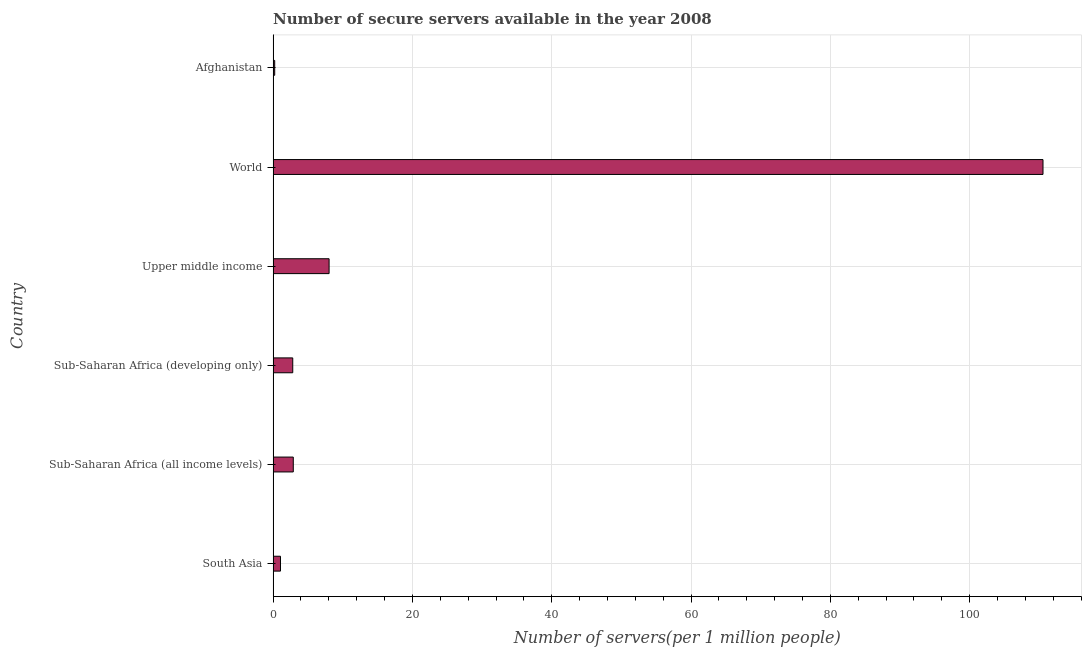Does the graph contain any zero values?
Your answer should be very brief. No. What is the title of the graph?
Offer a very short reply. Number of secure servers available in the year 2008. What is the label or title of the X-axis?
Your answer should be very brief. Number of servers(per 1 million people). What is the number of secure internet servers in Upper middle income?
Your response must be concise. 8.03. Across all countries, what is the maximum number of secure internet servers?
Keep it short and to the point. 110.53. Across all countries, what is the minimum number of secure internet servers?
Your response must be concise. 0.23. In which country was the number of secure internet servers maximum?
Provide a succinct answer. World. In which country was the number of secure internet servers minimum?
Give a very brief answer. Afghanistan. What is the sum of the number of secure internet servers?
Make the answer very short. 125.56. What is the difference between the number of secure internet servers in South Asia and World?
Provide a short and direct response. -109.47. What is the average number of secure internet servers per country?
Your answer should be compact. 20.93. What is the median number of secure internet servers?
Your answer should be very brief. 2.86. In how many countries, is the number of secure internet servers greater than 16 ?
Keep it short and to the point. 1. What is the ratio of the number of secure internet servers in South Asia to that in Sub-Saharan Africa (developing only)?
Your response must be concise. 0.38. Is the number of secure internet servers in Afghanistan less than that in World?
Your answer should be very brief. Yes. What is the difference between the highest and the second highest number of secure internet servers?
Ensure brevity in your answer.  102.49. Is the sum of the number of secure internet servers in Sub-Saharan Africa (developing only) and World greater than the maximum number of secure internet servers across all countries?
Your response must be concise. Yes. What is the difference between the highest and the lowest number of secure internet servers?
Your response must be concise. 110.3. How many bars are there?
Give a very brief answer. 6. What is the difference between two consecutive major ticks on the X-axis?
Your answer should be compact. 20. What is the Number of servers(per 1 million people) in South Asia?
Provide a succinct answer. 1.06. What is the Number of servers(per 1 million people) in Sub-Saharan Africa (all income levels)?
Keep it short and to the point. 2.9. What is the Number of servers(per 1 million people) in Sub-Saharan Africa (developing only)?
Keep it short and to the point. 2.82. What is the Number of servers(per 1 million people) of Upper middle income?
Provide a succinct answer. 8.03. What is the Number of servers(per 1 million people) in World?
Keep it short and to the point. 110.53. What is the Number of servers(per 1 million people) in Afghanistan?
Offer a terse response. 0.23. What is the difference between the Number of servers(per 1 million people) in South Asia and Sub-Saharan Africa (all income levels)?
Your answer should be compact. -1.84. What is the difference between the Number of servers(per 1 million people) in South Asia and Sub-Saharan Africa (developing only)?
Ensure brevity in your answer.  -1.76. What is the difference between the Number of servers(per 1 million people) in South Asia and Upper middle income?
Give a very brief answer. -6.98. What is the difference between the Number of servers(per 1 million people) in South Asia and World?
Ensure brevity in your answer.  -109.47. What is the difference between the Number of servers(per 1 million people) in South Asia and Afghanistan?
Your response must be concise. 0.83. What is the difference between the Number of servers(per 1 million people) in Sub-Saharan Africa (all income levels) and Sub-Saharan Africa (developing only)?
Keep it short and to the point. 0.08. What is the difference between the Number of servers(per 1 million people) in Sub-Saharan Africa (all income levels) and Upper middle income?
Provide a short and direct response. -5.14. What is the difference between the Number of servers(per 1 million people) in Sub-Saharan Africa (all income levels) and World?
Provide a succinct answer. -107.63. What is the difference between the Number of servers(per 1 million people) in Sub-Saharan Africa (all income levels) and Afghanistan?
Provide a short and direct response. 2.67. What is the difference between the Number of servers(per 1 million people) in Sub-Saharan Africa (developing only) and Upper middle income?
Your answer should be very brief. -5.22. What is the difference between the Number of servers(per 1 million people) in Sub-Saharan Africa (developing only) and World?
Make the answer very short. -107.71. What is the difference between the Number of servers(per 1 million people) in Sub-Saharan Africa (developing only) and Afghanistan?
Keep it short and to the point. 2.59. What is the difference between the Number of servers(per 1 million people) in Upper middle income and World?
Your answer should be compact. -102.49. What is the difference between the Number of servers(per 1 million people) in Upper middle income and Afghanistan?
Ensure brevity in your answer.  7.81. What is the difference between the Number of servers(per 1 million people) in World and Afghanistan?
Your answer should be compact. 110.3. What is the ratio of the Number of servers(per 1 million people) in South Asia to that in Sub-Saharan Africa (all income levels)?
Make the answer very short. 0.36. What is the ratio of the Number of servers(per 1 million people) in South Asia to that in Sub-Saharan Africa (developing only)?
Your answer should be compact. 0.38. What is the ratio of the Number of servers(per 1 million people) in South Asia to that in Upper middle income?
Provide a short and direct response. 0.13. What is the ratio of the Number of servers(per 1 million people) in South Asia to that in World?
Provide a succinct answer. 0.01. What is the ratio of the Number of servers(per 1 million people) in South Asia to that in Afghanistan?
Provide a short and direct response. 4.67. What is the ratio of the Number of servers(per 1 million people) in Sub-Saharan Africa (all income levels) to that in Sub-Saharan Africa (developing only)?
Provide a succinct answer. 1.03. What is the ratio of the Number of servers(per 1 million people) in Sub-Saharan Africa (all income levels) to that in Upper middle income?
Ensure brevity in your answer.  0.36. What is the ratio of the Number of servers(per 1 million people) in Sub-Saharan Africa (all income levels) to that in World?
Provide a short and direct response. 0.03. What is the ratio of the Number of servers(per 1 million people) in Sub-Saharan Africa (all income levels) to that in Afghanistan?
Give a very brief answer. 12.8. What is the ratio of the Number of servers(per 1 million people) in Sub-Saharan Africa (developing only) to that in Upper middle income?
Keep it short and to the point. 0.35. What is the ratio of the Number of servers(per 1 million people) in Sub-Saharan Africa (developing only) to that in World?
Make the answer very short. 0.03. What is the ratio of the Number of servers(per 1 million people) in Sub-Saharan Africa (developing only) to that in Afghanistan?
Keep it short and to the point. 12.46. What is the ratio of the Number of servers(per 1 million people) in Upper middle income to that in World?
Your answer should be compact. 0.07. What is the ratio of the Number of servers(per 1 million people) in Upper middle income to that in Afghanistan?
Your response must be concise. 35.53. What is the ratio of the Number of servers(per 1 million people) in World to that in Afghanistan?
Ensure brevity in your answer.  488.69. 